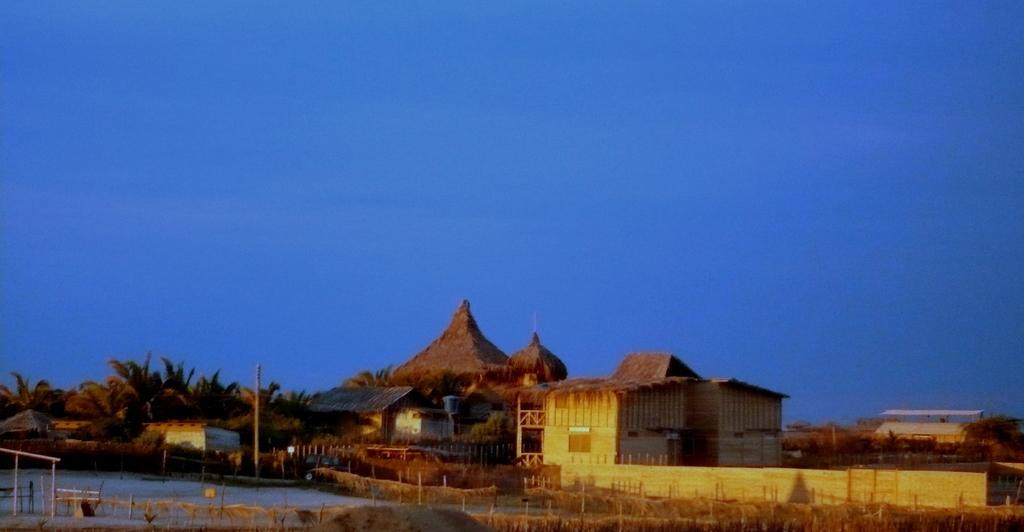What type of structures are visible in the image? There are huts in the image. What type of vegetation can be seen in the image? There are trees in the image. What body of water is present in the image? There is a lake in the image. What type of linen is draped over the trees in the image? There is no linen draped over the trees in the image; it only features huts, trees, and a lake. How does the flavor of the lake affect the taste of the huts in the image? The image does not depict any flavors or tastes associated with the lake or huts, so this question cannot be answered. 